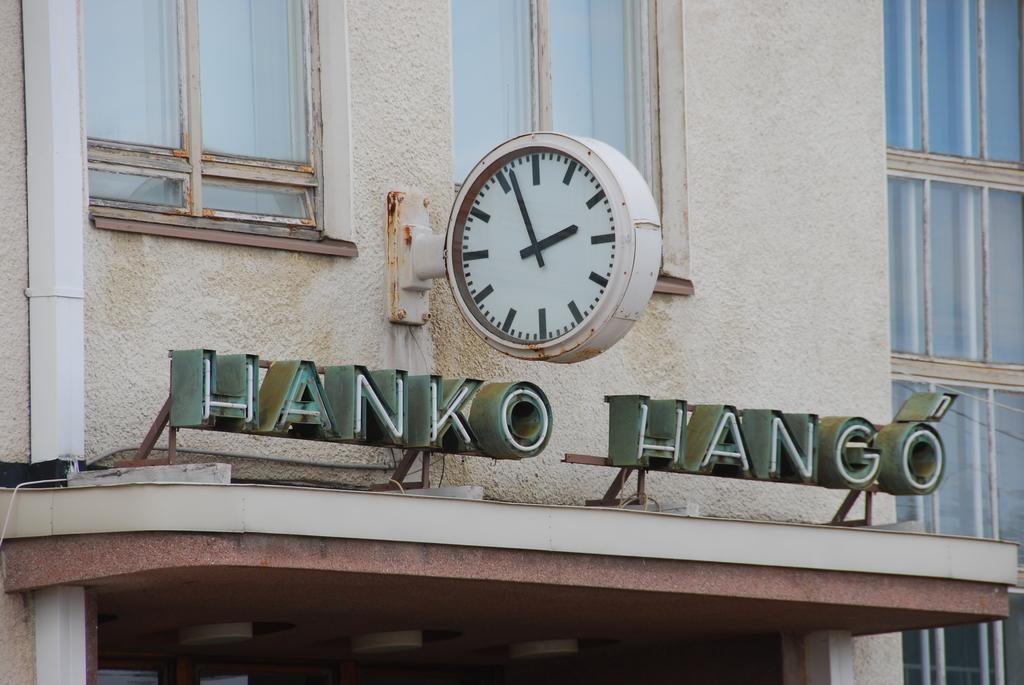<image>
Provide a brief description of the given image. A building with a clock hanging above the entrance and below the clock it says Hanko Hango. 